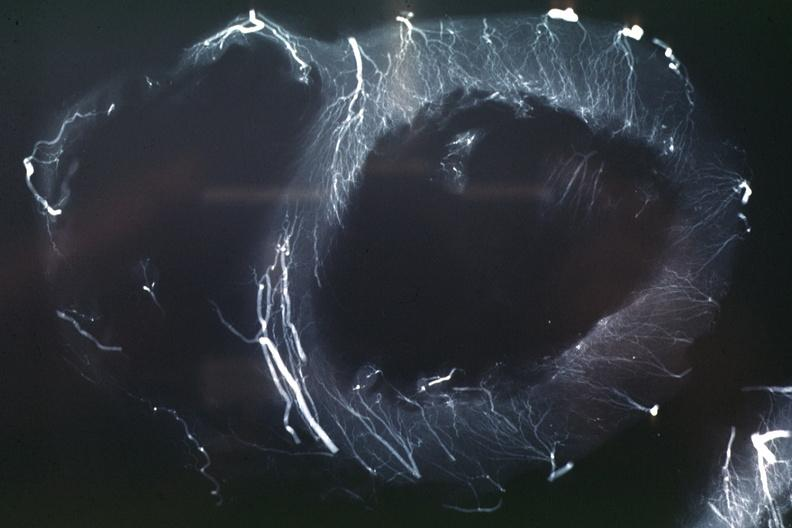where is this from?
Answer the question using a single word or phrase. Heart 